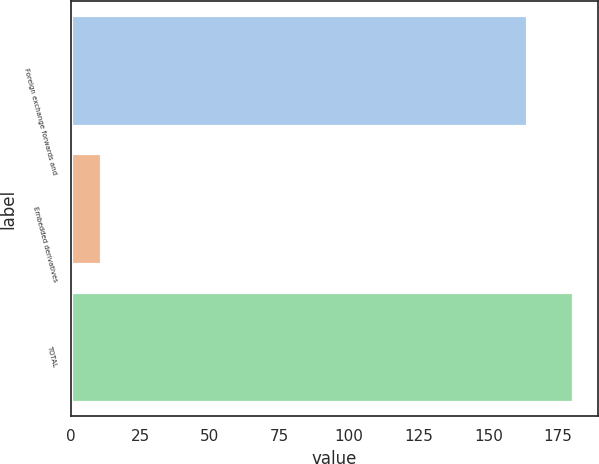<chart> <loc_0><loc_0><loc_500><loc_500><bar_chart><fcel>Foreign exchange forwards and<fcel>Embedded derivatives<fcel>TOTAL<nl><fcel>164<fcel>11<fcel>180.4<nl></chart> 